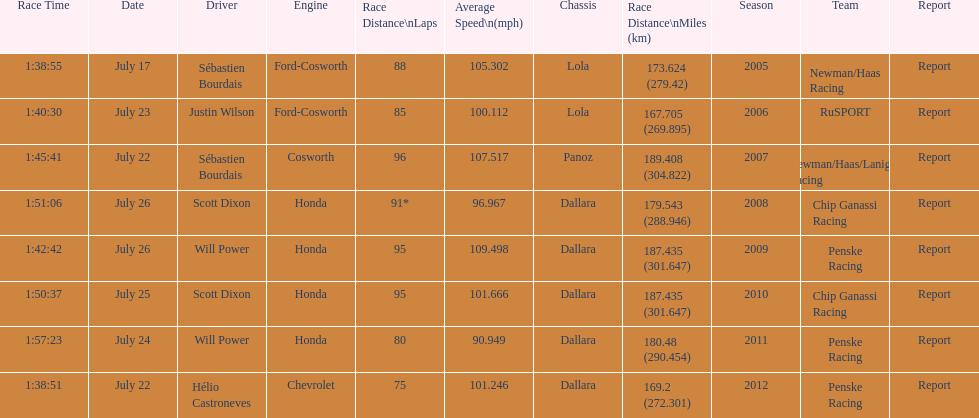How many different teams are represented in the table? 4. 